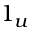Convert formula to latex. <formula><loc_0><loc_0><loc_500><loc_500>1 _ { u }</formula> 